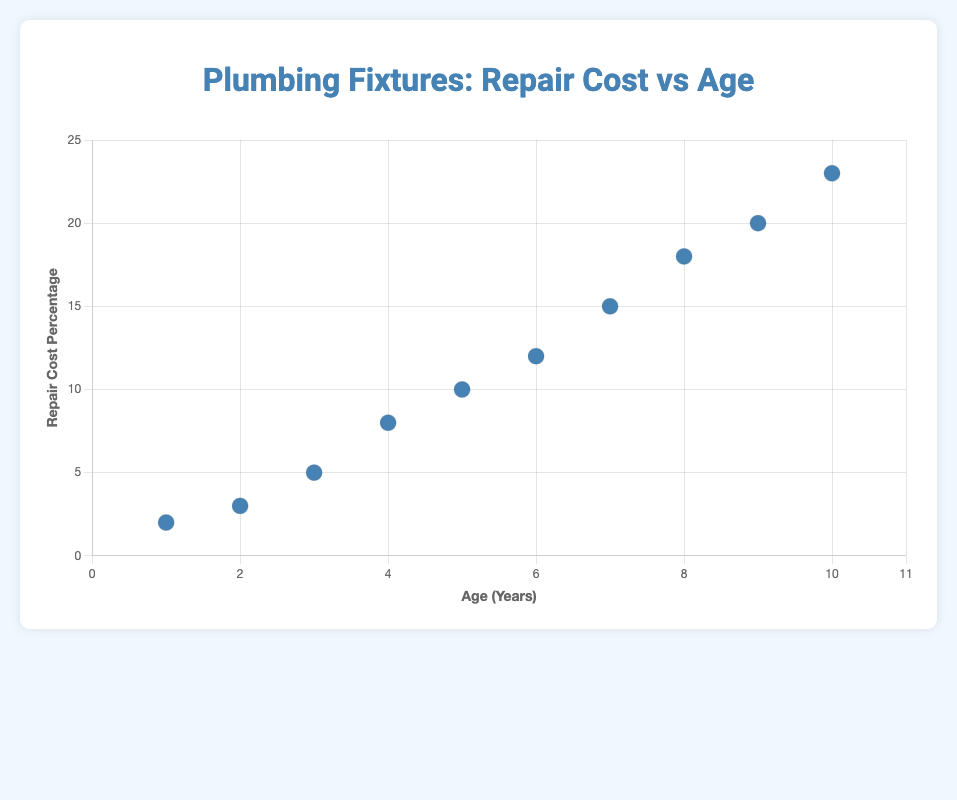How does age affect the cost of repairs? The scattered data shows that as the age of the plumbing fixtures increases, the repair cost percentage tends to increase. This is indicated by the rising pattern in the plotted data.
Answer: Increases What is the title of the chart? The title of the chart is displayed at the top and reads "Plumbing Fixtures: Repair Cost vs Age".
Answer: Plumbing Fixtures: Repair Cost vs Age What is the maximum age of the plumbing fixtures in the data? The x-axis represents the age of the plumbing fixtures, and the highest value marked is 10 years.
Answer: 10 years Which fixture has the lowest repair cost percentage? By looking at the plotted points, the Delta Faucet at 1 year has the lowest repair cost percentage, which is 2%.
Answer: Delta Faucet What is the average repair cost percentage for fixtures aged 5 years and older? The repair cost percentages for 5 years and older are 10, 12, 15, 18, 20, and 23. Summing these gives 98 and dividing by the number of fixtures (6) gives an average of 16.33%.
Answer: 16.33% Is there a clear trend in the chart? Yes, there is a clear upward trend, indicating that the repair cost percentage increases as the years pass.
Answer: Yes Which fixture has the highest repair cost percentage and what is it? The Gerber Urinal, at 10 years, has the highest repair cost percentage, which is 23%.
Answer: Gerber Urinal, 23% Can you state how much the repair cost percentage increases on average per year? The x-axis range is from 1 to 10 years, and the y-axis range is from 2% to 23%. The overall increase in repair cost percentage is 21% (from 2% to 23%) over 9 years, so the average increase per year is 21/9 = 2.33%.
Answer: 2.33% 